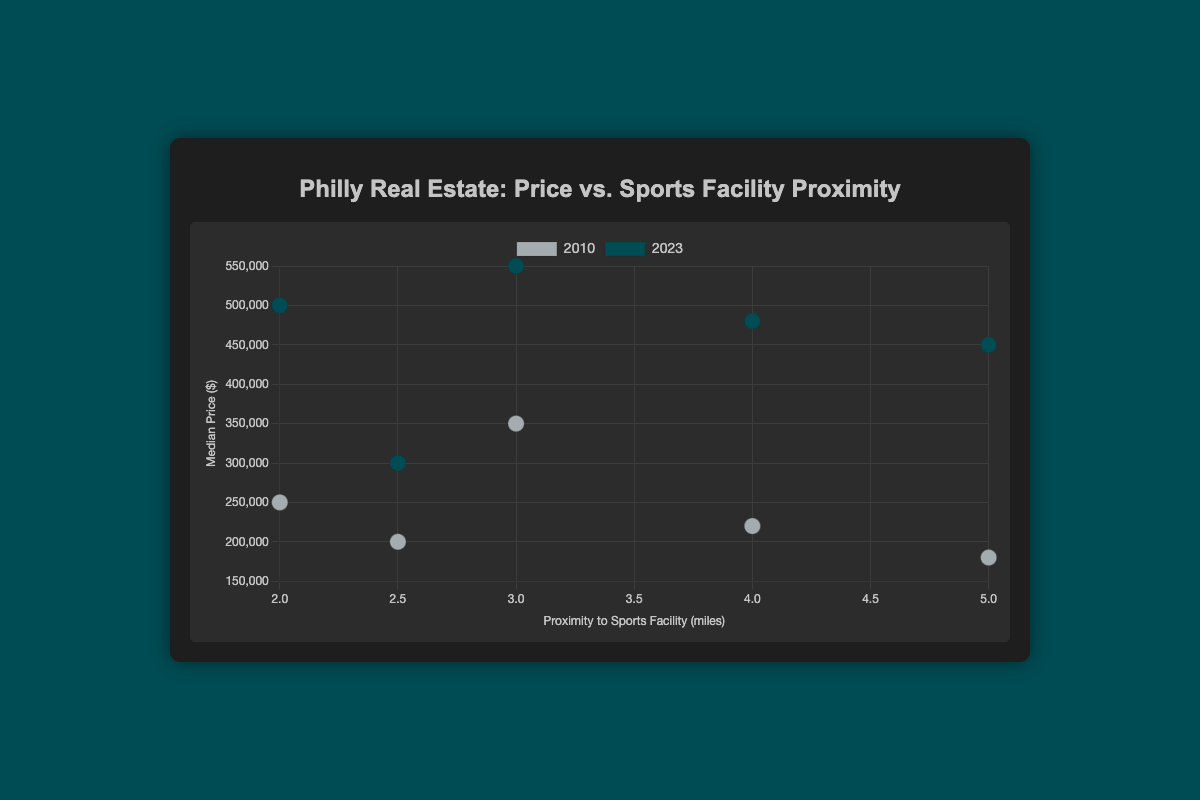What is the title of the figure? The title is displayed prominently at the top of the figure within the container element.
Answer: Philly Real Estate: Price vs. Sports Facility Proximity What do the x-axis and y-axis represent in the figure? The x-axis title and the y-axis title are part of the chart and represented by text on the respective axes.
Answer: Proximity to Sports Facility (miles) and Median Price ($) How does the color differentiate between data points in the scatter plot? By examining the colors of the points in the datasets, we can see that they are differentiated by year - grey for 2010 and dark green for 2023.
Answer: Grey represents 2010 and dark green represents 2023 Which neighborhood had the highest median price in 2023? By looking at the dark green points and identifying which one is the highest on the y-axis, we can see that Center City has the highest median price.
Answer: Center City What is the trend observed in the South Philadelphia neighborhood from 2010 to 2023? By comparing the positions of the grey and dark green points for South Philadelphia, we see that the median price increased from 200,000 to 300,000 while the proximity remained the same.
Answer: Median price increased from 200,000 to 300,000 Which neighborhood experienced the largest increase in median price from 2010 to 2023? By comparing the difference in median prices for each neighborhood from 2010 to 2023 and finding the largest change, Fishtown has the largest increase (from 180,000 to 450,000).
Answer: Fishtown Is there a general trend between proximity to sports facilities and median price in 2023? By examining the dark green points' trend, closer proximity (1-3 miles) tends to show higher prices, while further distances (4-5 miles) have slightly lower prices. A general trend is observed, but there may be exceptions.
Answer: Closer proximity tends to correlate with higher prices Compare the median price of Center City and University City in 2010. Which one is higher, and by how much? By observing the grey points for Center City and University City, Center City (350,000) is higher than University City (250,000) by 100,000.
Answer: Center City by 100,000 How many data points are there for each year in the scatter plot? By identifying the points' colors and counting the grey points for 2010 and the dark green for 2023, both years have five data points each.
Answer: Five for each year Which neighborhood was the farthest from sports facilities, and what was the median price there in 2023? By identifying the dark green point farthest to the right on the x-axis, Fishtown is 5 miles away with a median price of 450,000.
Answer: Fishtown, 450,000 